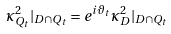Convert formula to latex. <formula><loc_0><loc_0><loc_500><loc_500>\kappa ^ { 2 } _ { Q _ { t } } | _ { D \cap Q _ { t } } = e ^ { i \vartheta _ { t } } \kappa ^ { 2 } _ { D } | _ { D \cap Q _ { t } }</formula> 